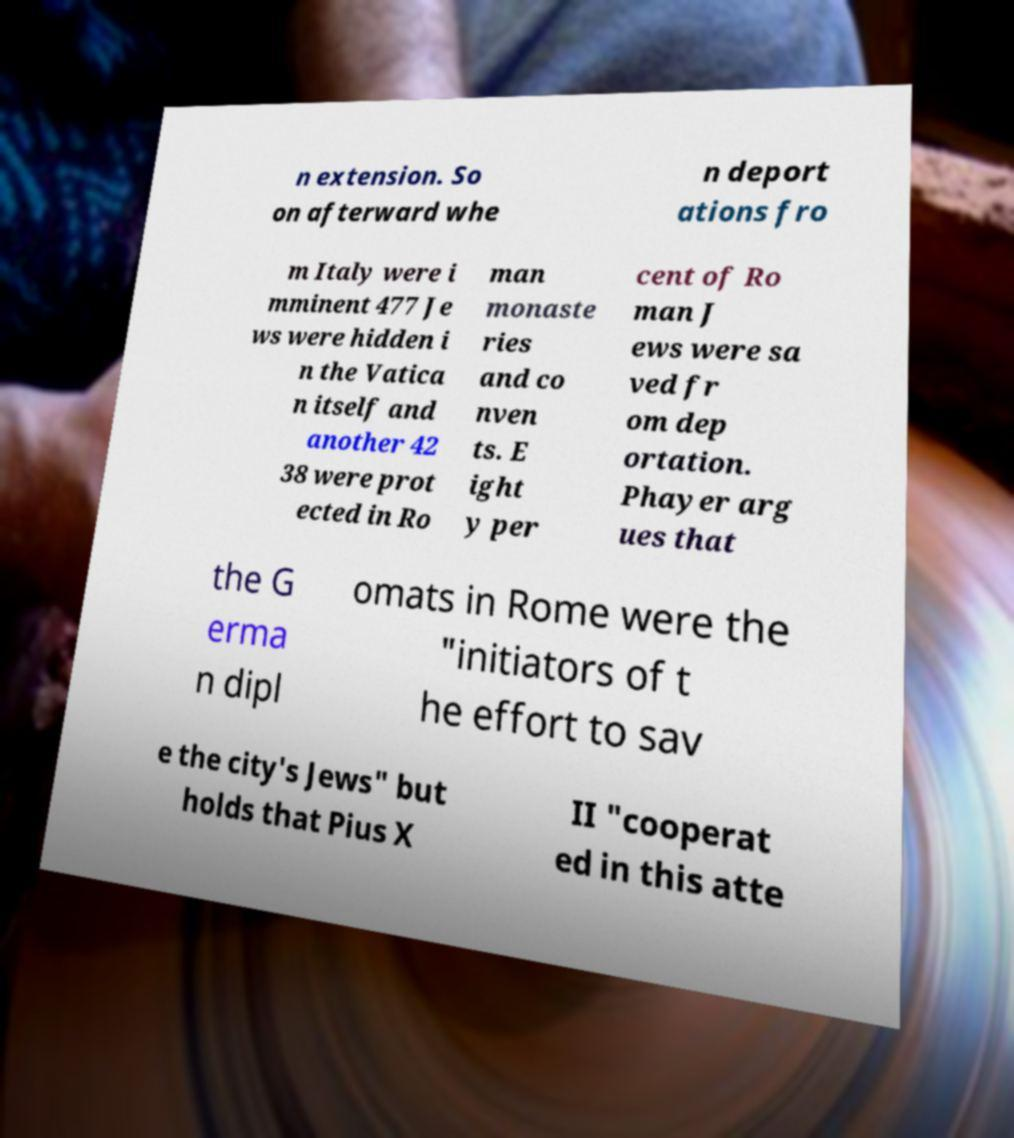For documentation purposes, I need the text within this image transcribed. Could you provide that? n extension. So on afterward whe n deport ations fro m Italy were i mminent 477 Je ws were hidden i n the Vatica n itself and another 42 38 were prot ected in Ro man monaste ries and co nven ts. E ight y per cent of Ro man J ews were sa ved fr om dep ortation. Phayer arg ues that the G erma n dipl omats in Rome were the "initiators of t he effort to sav e the city's Jews" but holds that Pius X II "cooperat ed in this atte 